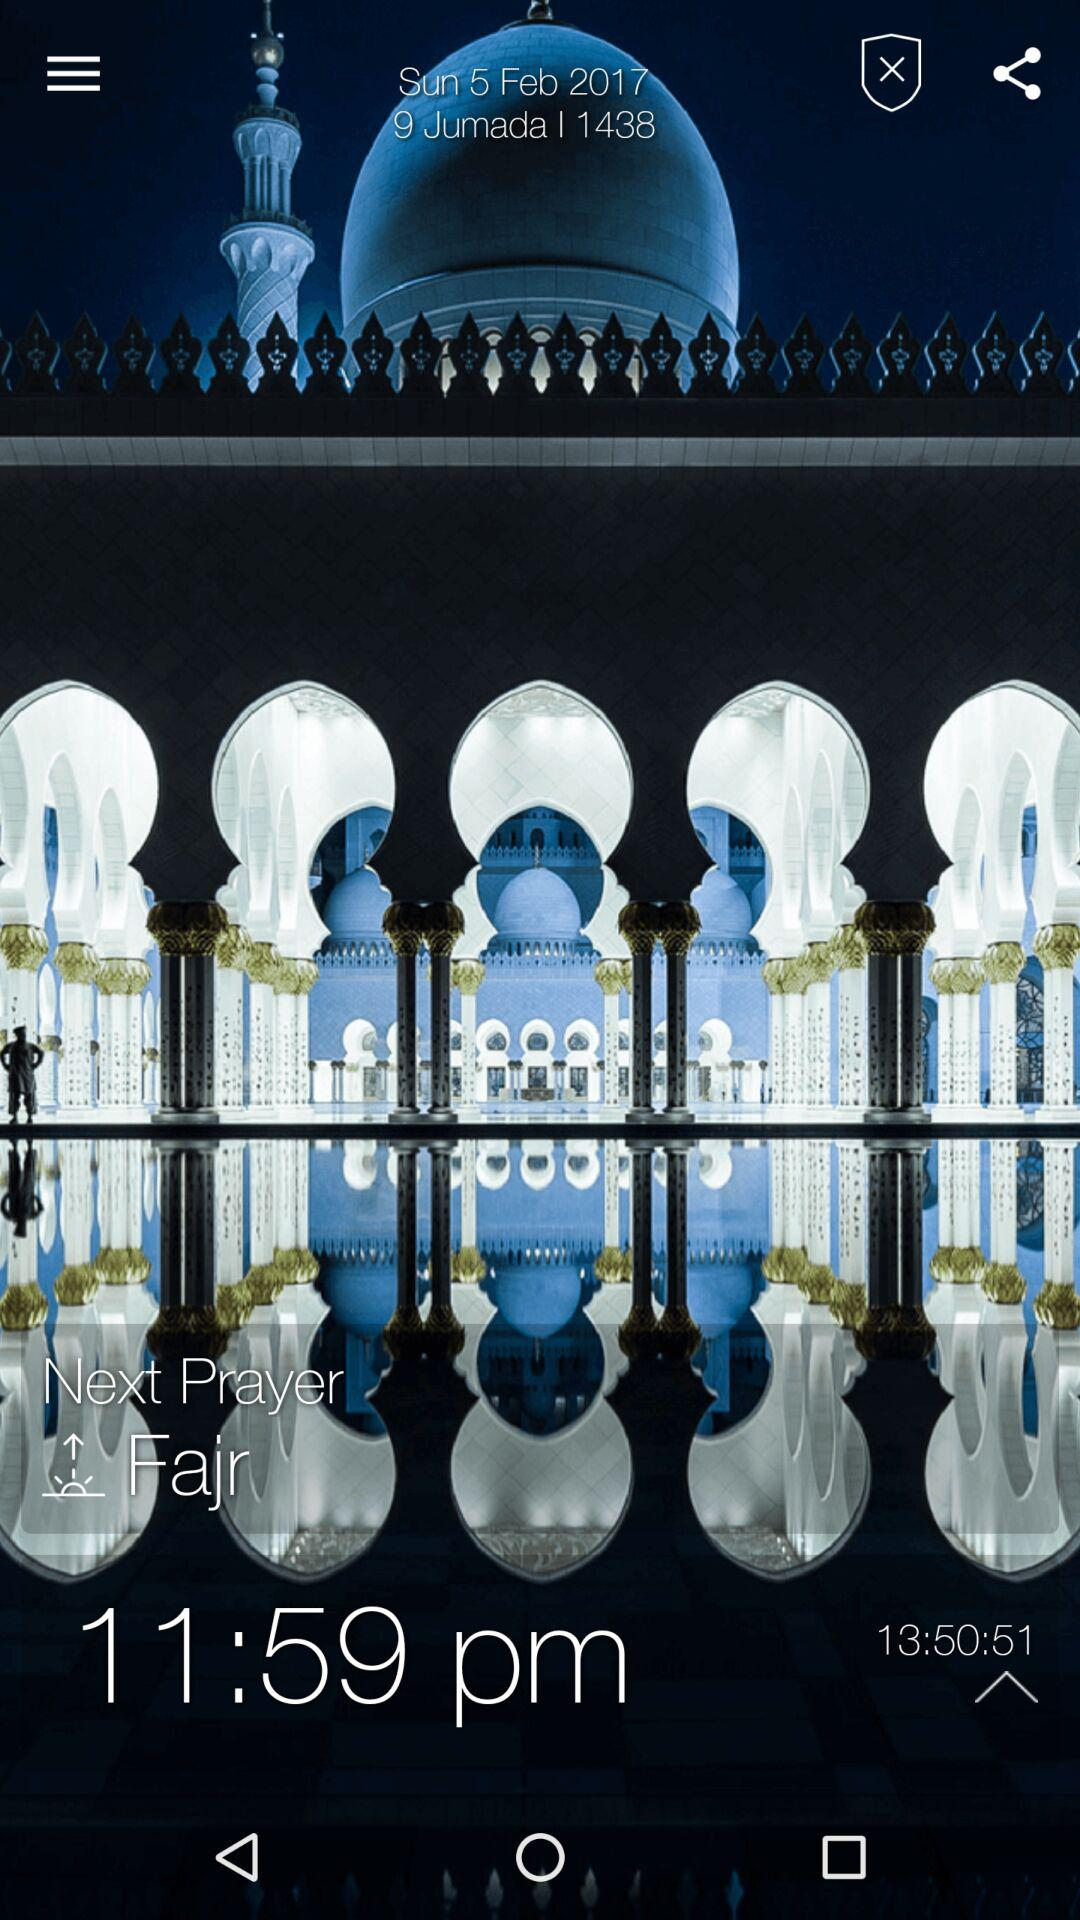What date and time are shown on the screen? The date and time shown on the screen are Sunday, February 5, 2017 and 11:59 p.m., respectively. 